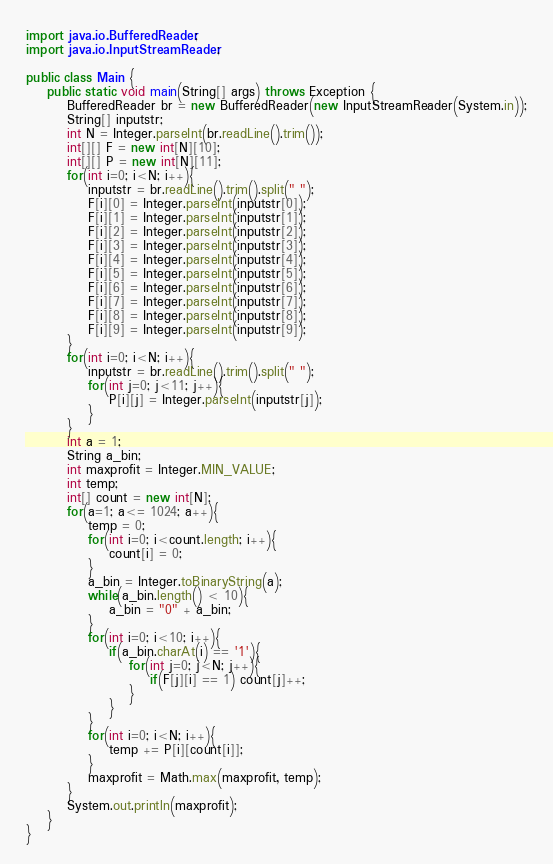Convert code to text. <code><loc_0><loc_0><loc_500><loc_500><_Java_>

import java.io.BufferedReader;
import java.io.InputStreamReader;

public class Main {
    public static void main(String[] args) throws Exception {
        BufferedReader br = new BufferedReader(new InputStreamReader(System.in));
        String[] inputstr;
        int N = Integer.parseInt(br.readLine().trim());
        int[][] F = new int[N][10];
        int[][] P = new int[N][11];
        for(int i=0; i<N; i++){
            inputstr = br.readLine().trim().split(" ");
            F[i][0] = Integer.parseInt(inputstr[0]);
            F[i][1] = Integer.parseInt(inputstr[1]);
            F[i][2] = Integer.parseInt(inputstr[2]);
            F[i][3] = Integer.parseInt(inputstr[3]);
            F[i][4] = Integer.parseInt(inputstr[4]);
            F[i][5] = Integer.parseInt(inputstr[5]);
            F[i][6] = Integer.parseInt(inputstr[6]);
            F[i][7] = Integer.parseInt(inputstr[7]);
            F[i][8] = Integer.parseInt(inputstr[8]);
            F[i][9] = Integer.parseInt(inputstr[9]);
        }
        for(int i=0; i<N; i++){
            inputstr = br.readLine().trim().split(" ");
            for(int j=0; j<11; j++){
                P[i][j] = Integer.parseInt(inputstr[j]);
            }
        }
        int a = 1;
        String a_bin;
        int maxprofit = Integer.MIN_VALUE;
        int temp;
        int[] count = new int[N];
        for(a=1; a<= 1024; a++){
            temp = 0;
            for(int i=0; i<count.length; i++){
                count[i] = 0;
            }
            a_bin = Integer.toBinaryString(a);
            while(a_bin.length() < 10){
                a_bin = "0" + a_bin;
            }
            for(int i=0; i<10; i++){
                if(a_bin.charAt(i) == '1'){
                    for(int j=0; j<N; j++){
                        if(F[j][i] == 1) count[j]++;
                    }
                }
            }
            for(int i=0; i<N; i++){
                temp += P[i][count[i]];
            }
            maxprofit = Math.max(maxprofit, temp);
        }
        System.out.println(maxprofit);
    }
}</code> 